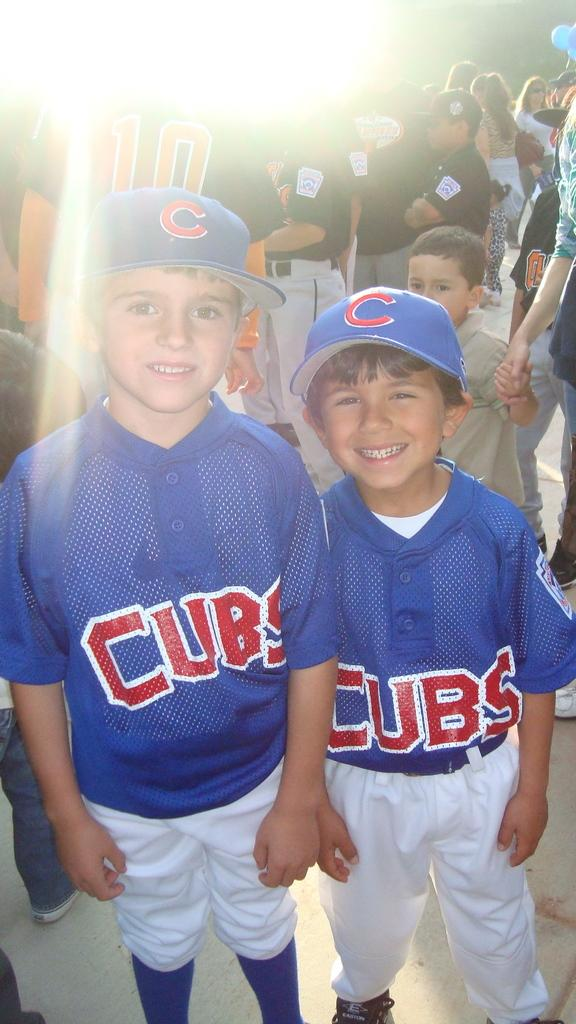<image>
Summarize the visual content of the image. A couple of boys in Cubs baseball uniforms and wearing a C baseball cap 